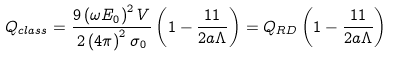Convert formula to latex. <formula><loc_0><loc_0><loc_500><loc_500>Q _ { c l a s s } = \frac { 9 \left ( \omega E _ { 0 } \right ) ^ { 2 } V } { 2 \left ( 4 \pi \right ) ^ { 2 } \sigma _ { 0 } } \left ( 1 - \frac { 1 1 } { 2 a \Lambda } \right ) = Q _ { R D } \left ( 1 - \frac { 1 1 } { 2 a \Lambda } \right )</formula> 